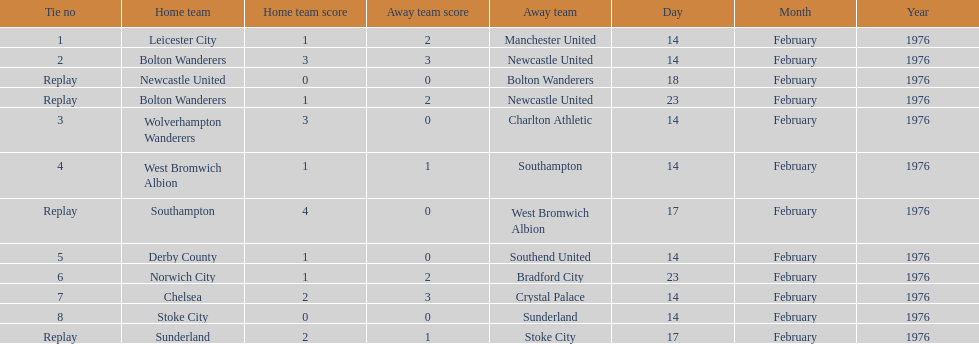What was the number of games that occurred on 14 february 1976? 7. 